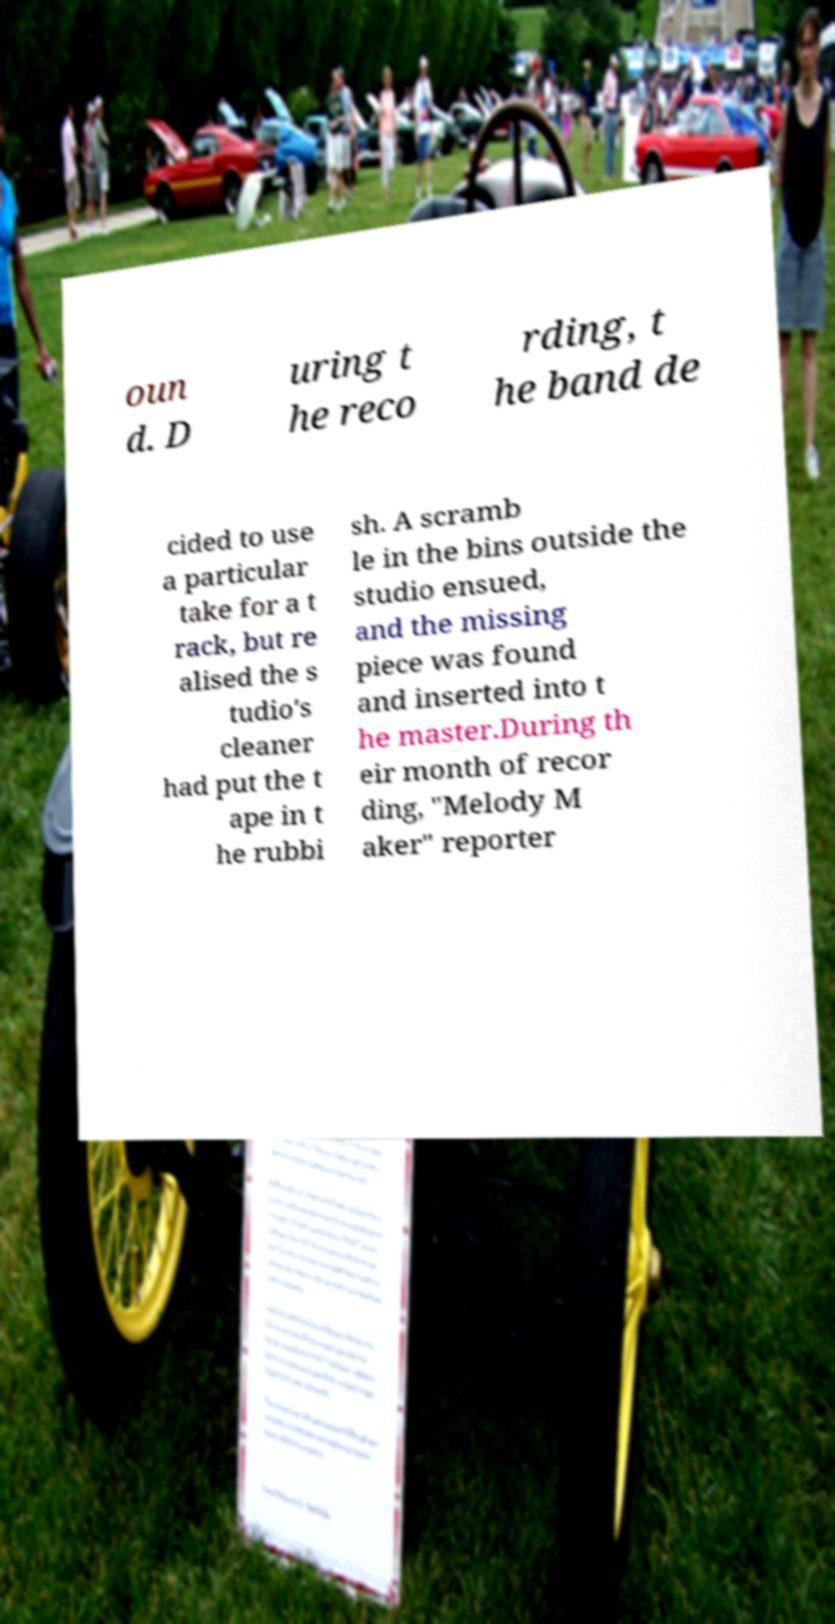What messages or text are displayed in this image? I need them in a readable, typed format. oun d. D uring t he reco rding, t he band de cided to use a particular take for a t rack, but re alised the s tudio's cleaner had put the t ape in t he rubbi sh. A scramb le in the bins outside the studio ensued, and the missing piece was found and inserted into t he master.During th eir month of recor ding, "Melody M aker" reporter 